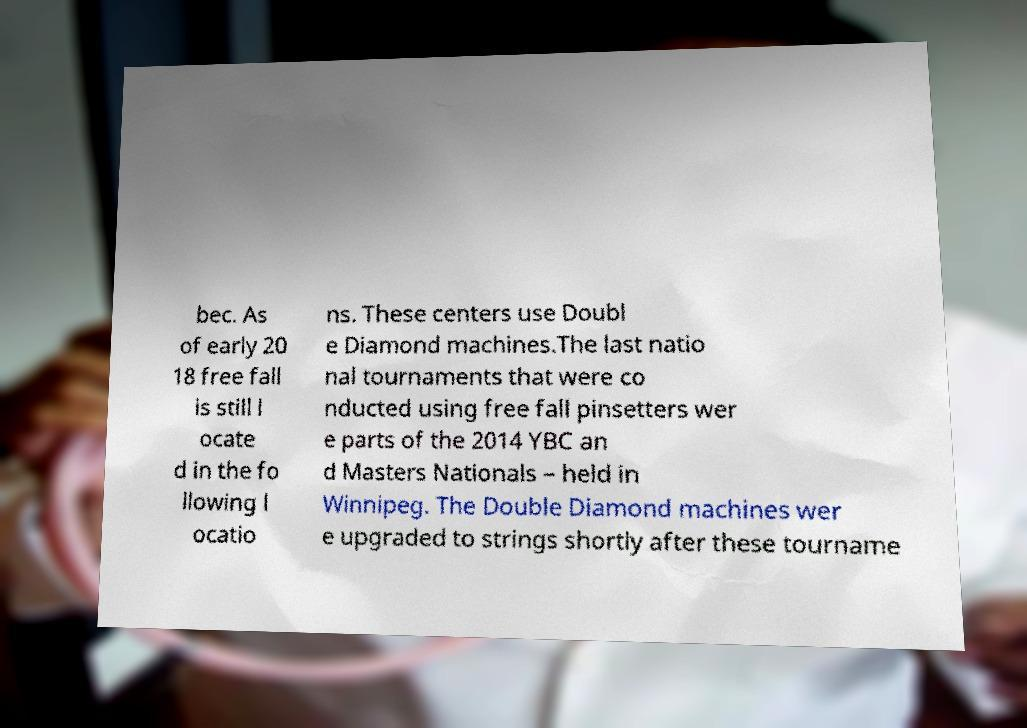What messages or text are displayed in this image? I need them in a readable, typed format. bec. As of early 20 18 free fall is still l ocate d in the fo llowing l ocatio ns. These centers use Doubl e Diamond machines.The last natio nal tournaments that were co nducted using free fall pinsetters wer e parts of the 2014 YBC an d Masters Nationals – held in Winnipeg. The Double Diamond machines wer e upgraded to strings shortly after these tourname 